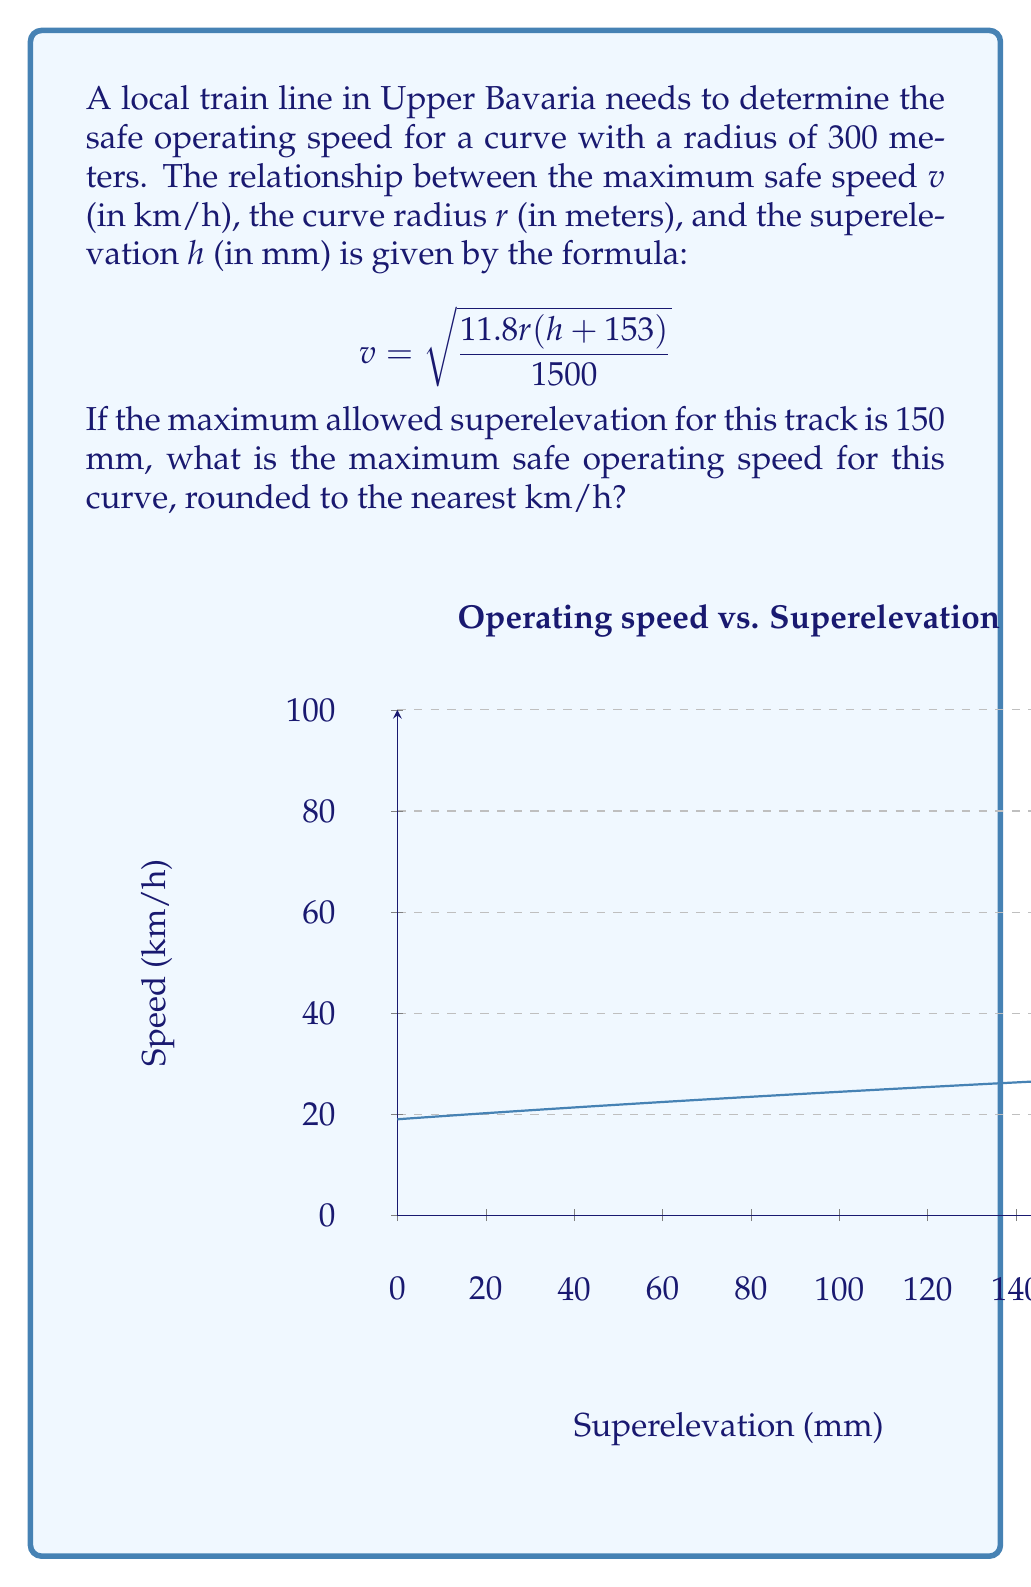Help me with this question. Let's approach this step-by-step:

1) We are given the formula: 
   $$v = \sqrt{\frac{11.8r(h+153)}{1500}}$$

2) We know:
   - Curve radius $r = 300$ meters
   - Maximum superelevation $h = 150$ mm

3) Let's substitute these values into the formula:
   $$v = \sqrt{\frac{11.8 \cdot 300(150+153)}{1500}}$$

4) Simplify inside the parentheses:
   $$v = \sqrt{\frac{11.8 \cdot 300 \cdot 303}{1500}}$$

5) Multiply the numerator:
   $$v = \sqrt{\frac{1072980}{1500}}$$

6) Divide inside the square root:
   $$v = \sqrt{715.32}$$

7) Calculate the square root:
   $$v \approx 26.74615$$

8) Rounding to the nearest km/h:
   $$v \approx 27$$ km/h

Therefore, the maximum safe operating speed for this curve is 27 km/h.
Answer: 27 km/h 